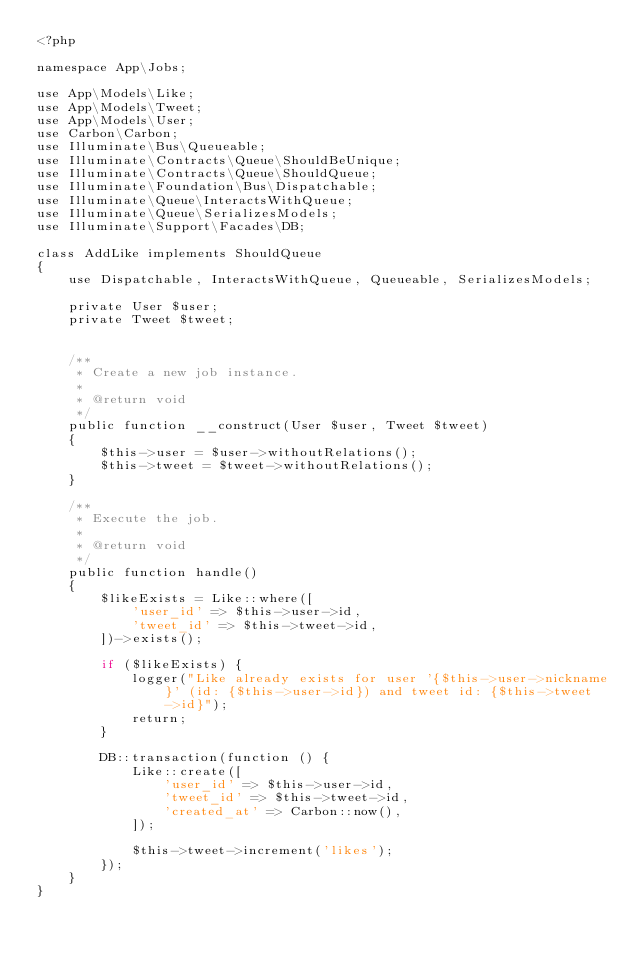<code> <loc_0><loc_0><loc_500><loc_500><_PHP_><?php

namespace App\Jobs;

use App\Models\Like;
use App\Models\Tweet;
use App\Models\User;
use Carbon\Carbon;
use Illuminate\Bus\Queueable;
use Illuminate\Contracts\Queue\ShouldBeUnique;
use Illuminate\Contracts\Queue\ShouldQueue;
use Illuminate\Foundation\Bus\Dispatchable;
use Illuminate\Queue\InteractsWithQueue;
use Illuminate\Queue\SerializesModels;
use Illuminate\Support\Facades\DB;

class AddLike implements ShouldQueue
{
    use Dispatchable, InteractsWithQueue, Queueable, SerializesModels;

    private User $user;
    private Tweet $tweet;


    /**
     * Create a new job instance.
     *
     * @return void
     */
    public function __construct(User $user, Tweet $tweet)
    {
        $this->user = $user->withoutRelations();
        $this->tweet = $tweet->withoutRelations();
    }

    /**
     * Execute the job.
     *
     * @return void
     */
    public function handle()
    {
        $likeExists = Like::where([
            'user_id' => $this->user->id,
            'tweet_id' => $this->tweet->id,
        ])->exists();

        if ($likeExists) {
            logger("Like already exists for user '{$this->user->nickname}' (id: {$this->user->id}) and tweet id: {$this->tweet->id}");
            return;
        }

        DB::transaction(function () {
            Like::create([
                'user_id' => $this->user->id,
                'tweet_id' => $this->tweet->id,
                'created_at' => Carbon::now(),
            ]);

            $this->tweet->increment('likes');
        });
    }
}
</code> 